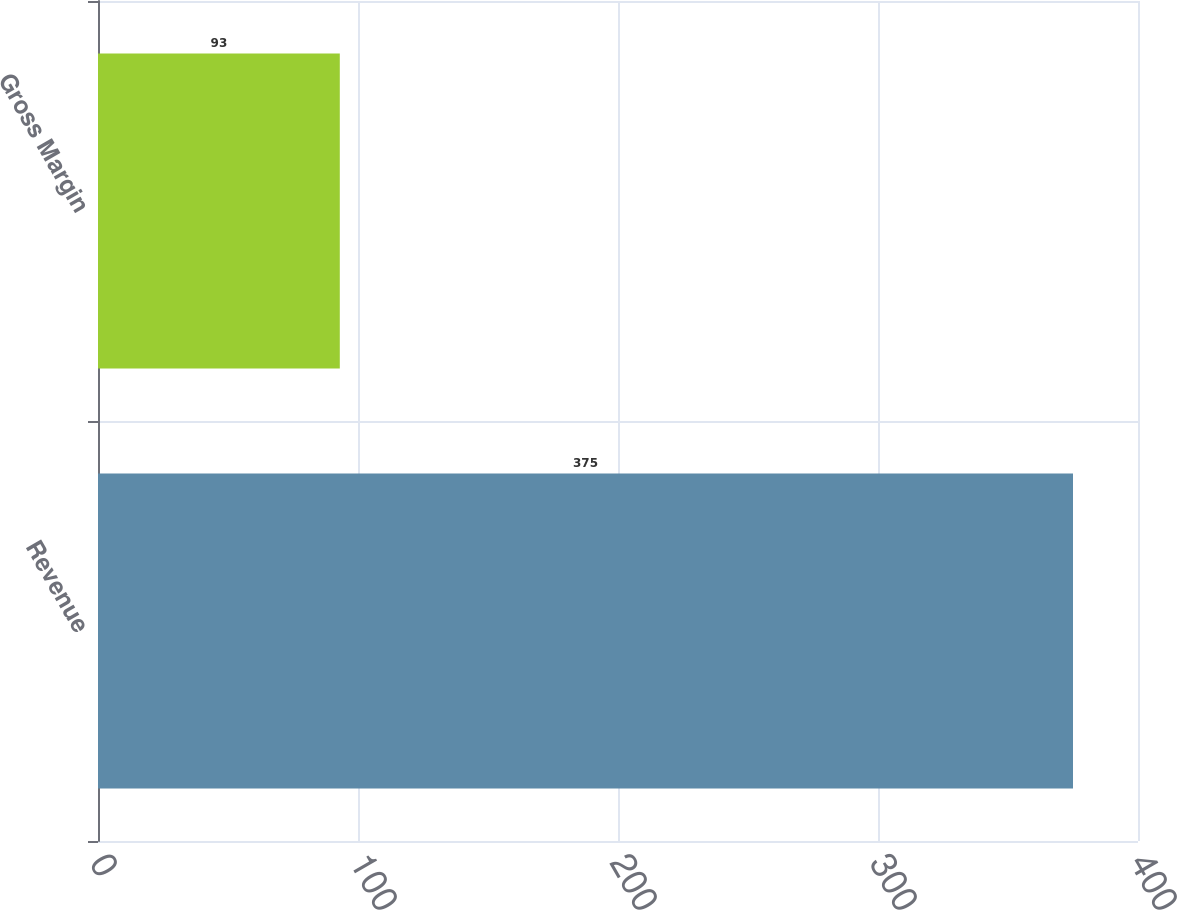<chart> <loc_0><loc_0><loc_500><loc_500><bar_chart><fcel>Revenue<fcel>Gross Margin<nl><fcel>375<fcel>93<nl></chart> 